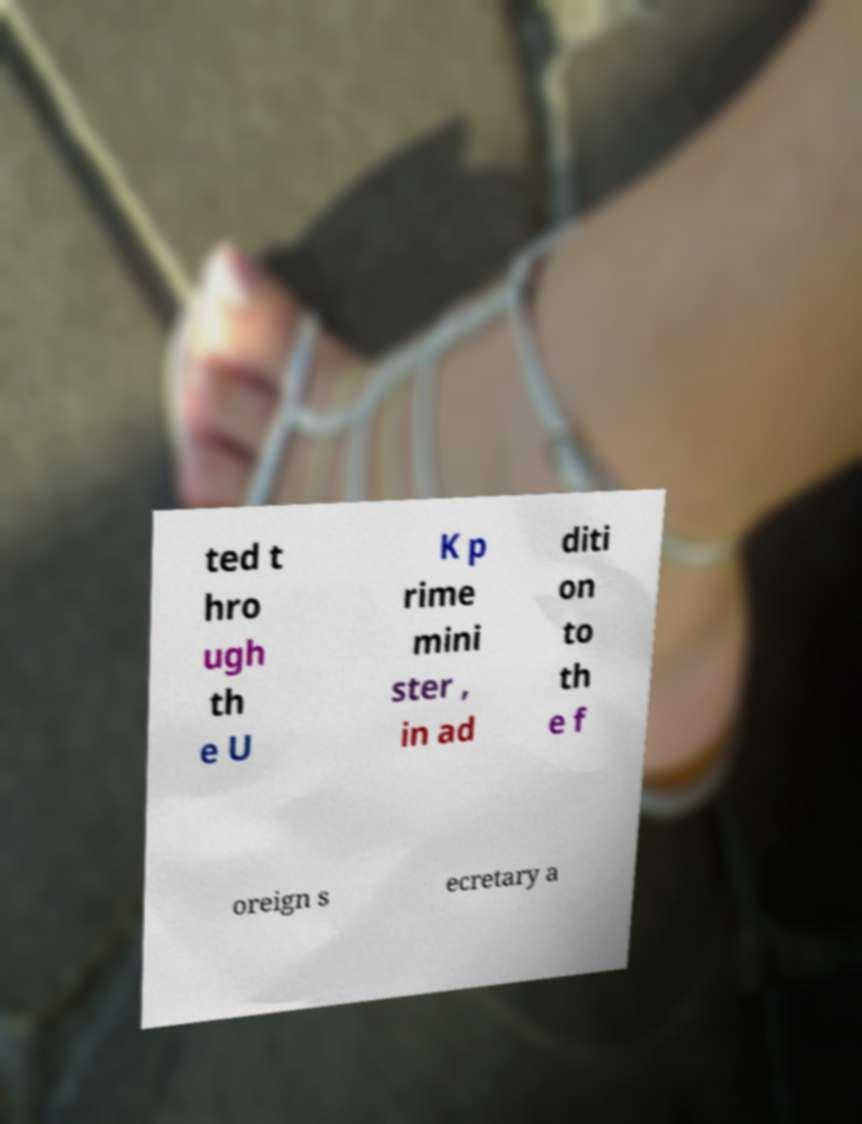There's text embedded in this image that I need extracted. Can you transcribe it verbatim? ted t hro ugh th e U K p rime mini ster , in ad diti on to th e f oreign s ecretary a 